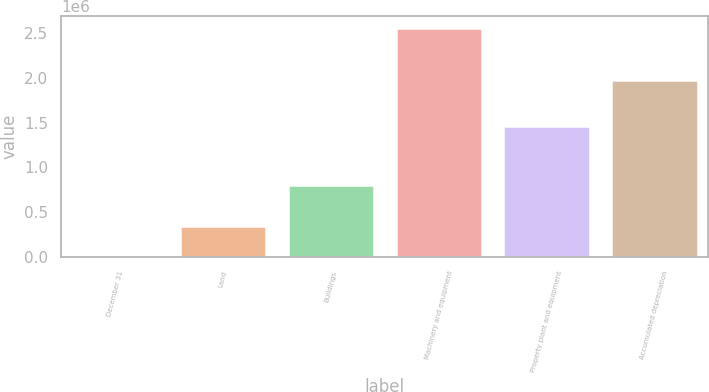Convert chart to OTSL. <chart><loc_0><loc_0><loc_500><loc_500><bar_chart><fcel>December 31<fcel>Land<fcel>Buildings<fcel>Machinery and equipment<fcel>Property plant and equipment<fcel>Accumulated depreciation<nl><fcel>2008<fcel>345549<fcel>805736<fcel>2.56146e+06<fcel>1.45895e+06<fcel>1.97847e+06<nl></chart> 